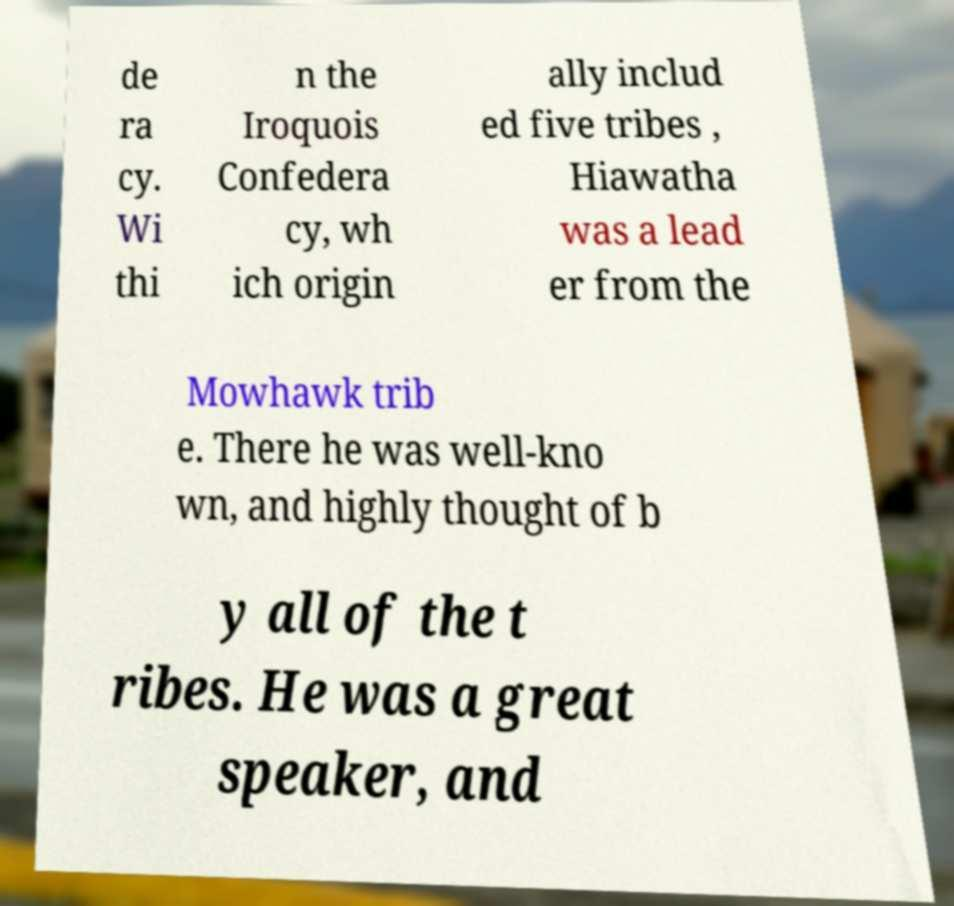Could you assist in decoding the text presented in this image and type it out clearly? de ra cy. Wi thi n the Iroquois Confedera cy, wh ich origin ally includ ed five tribes , Hiawatha was a lead er from the Mowhawk trib e. There he was well-kno wn, and highly thought of b y all of the t ribes. He was a great speaker, and 